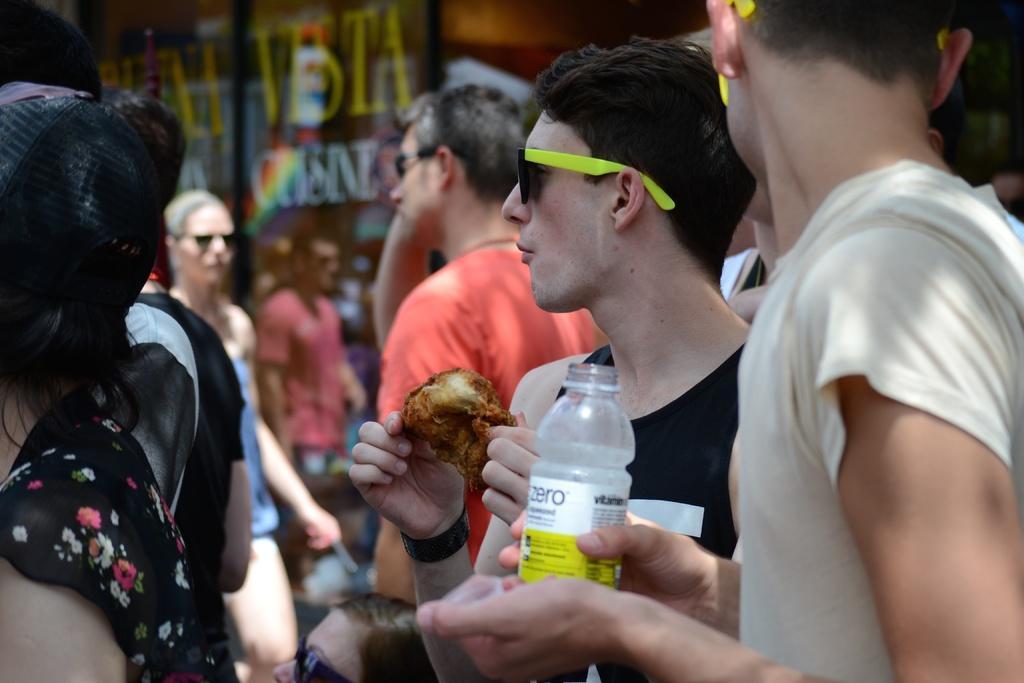In one or two sentences, can you explain what this image depicts? people are standing on the street. the person at the right is wearing a cream t shirt holding a bottle in his hand. behind him a person is standing wearing a black t shirt and holding a food item in his hand, he is wearing black and yellow goggles. behind him a person is standing wearing a red t shirt. at the back there is a banner. 